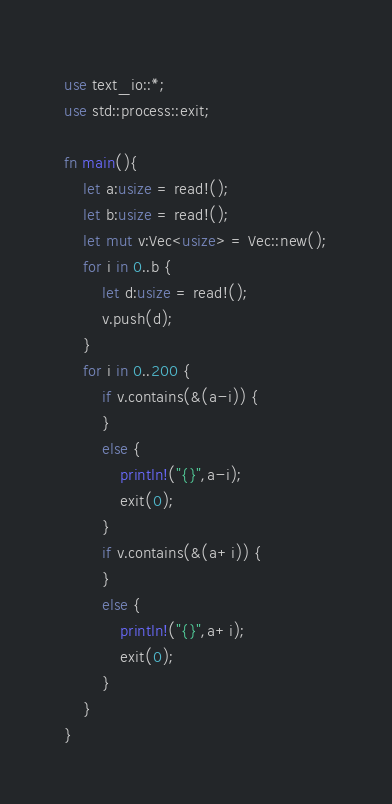<code> <loc_0><loc_0><loc_500><loc_500><_Rust_>use text_io::*;
use std::process::exit;

fn main(){
    let a:usize = read!();
    let b:usize = read!();
    let mut v:Vec<usize> = Vec::new();
    for i in 0..b {
        let d:usize = read!();
        v.push(d);
    }
    for i in 0..200 {
        if v.contains(&(a-i)) {
        }
        else {
            println!("{}",a-i);
            exit(0);
        }
        if v.contains(&(a+i)) {
        }
        else {
            println!("{}",a+i);
            exit(0);
        }
    }
}</code> 